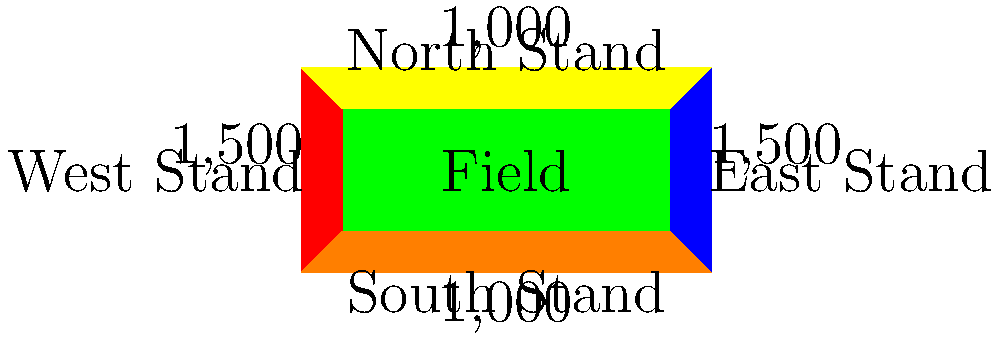Based on the simplified stadium diagram of the Philadelphia Ukrainian Nationals Soccer Team's home ground, what is the total seating capacity of the stadium? To determine the total seating capacity of the stadium, we need to add up the capacity of each stand:

1. West Stand: 1,500 seats
2. East Stand: 1,500 seats
3. North Stand: 1,000 seats
4. South Stand: 1,000 seats

Calculating the total:
$$ \text{Total Capacity} = 1,500 + 1,500 + 1,000 + 1,000 = 5,000 $$

Therefore, the total seating capacity of the Philadelphia Ukrainian Nationals Soccer Team's home stadium is 5,000 seats.
Answer: 5,000 seats 